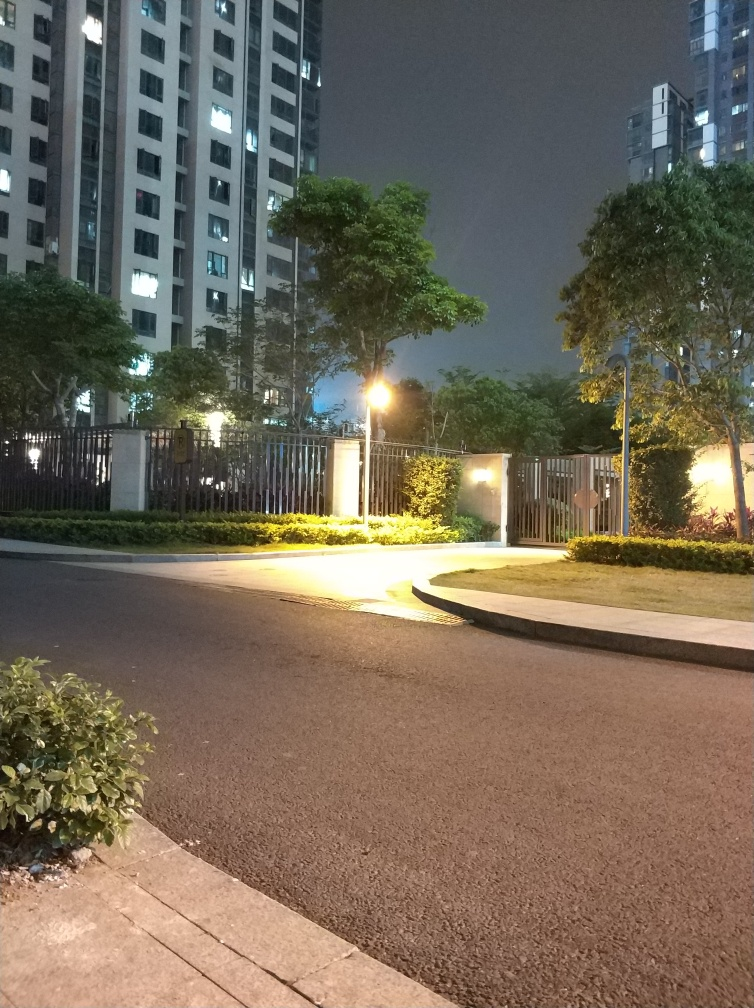What time of day does this photo seem to be taken? Considering the darkness in the sky and the artificial lighting on the ground, it appears that the photo was taken at nighttime. 